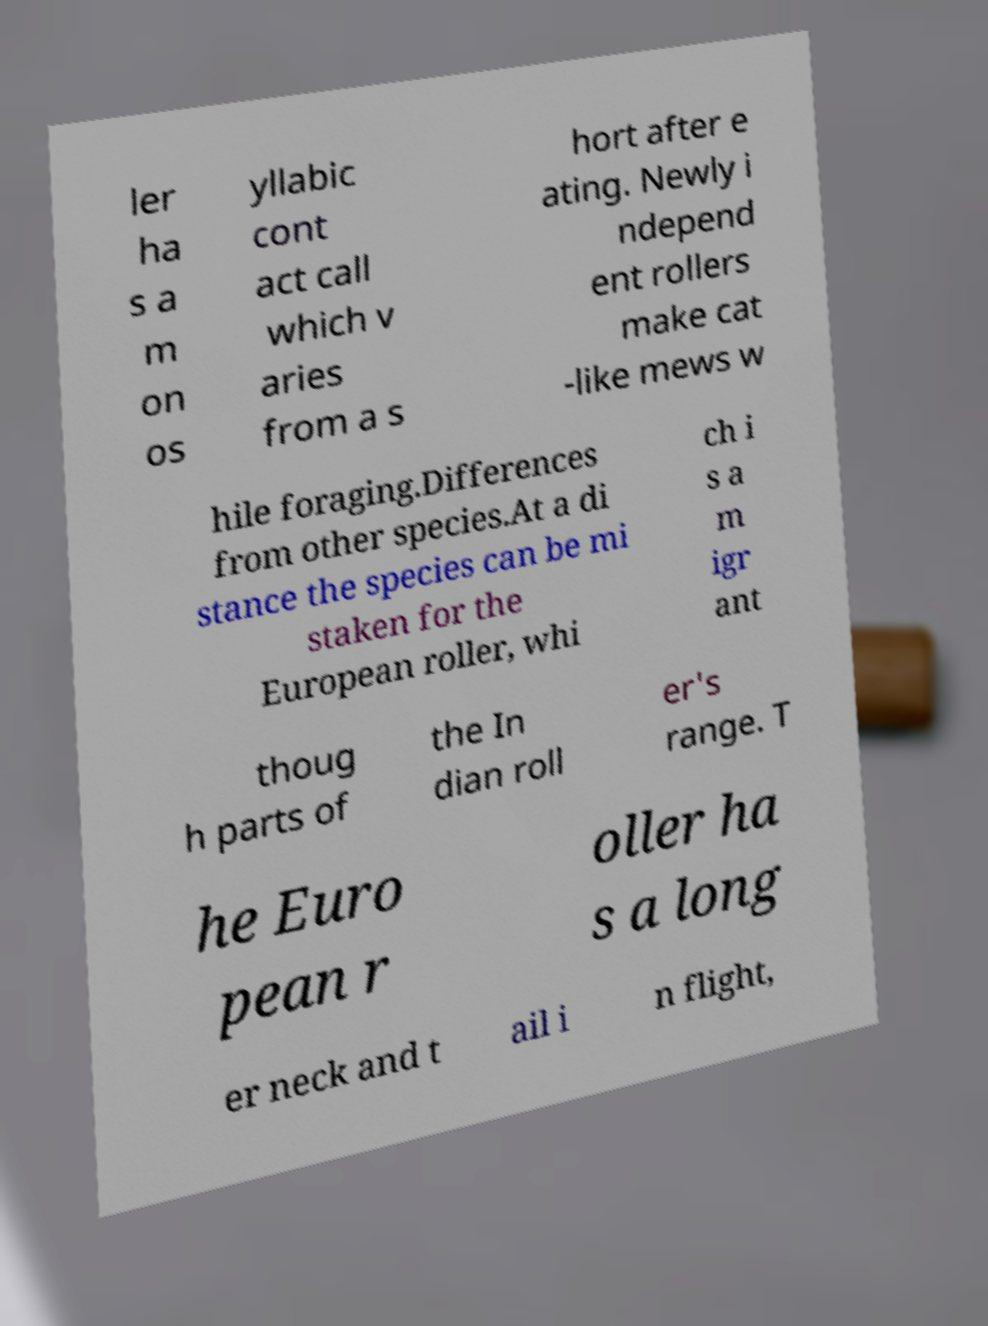I need the written content from this picture converted into text. Can you do that? ler ha s a m on os yllabic cont act call which v aries from a s hort after e ating. Newly i ndepend ent rollers make cat -like mews w hile foraging.Differences from other species.At a di stance the species can be mi staken for the European roller, whi ch i s a m igr ant thoug h parts of the In dian roll er's range. T he Euro pean r oller ha s a long er neck and t ail i n flight, 